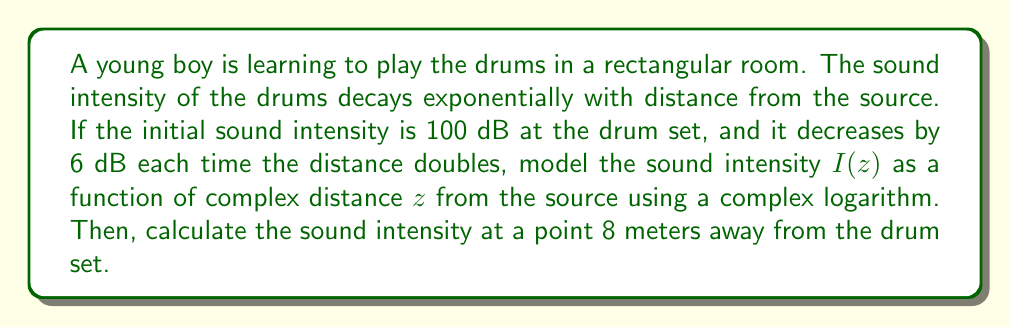Could you help me with this problem? Let's approach this problem step by step:

1) First, we need to understand the relationship between sound intensity and distance. The given information states that the intensity decreases by 6 dB each time the distance doubles. This is a logarithmic relationship.

2) We can model this using the complex logarithm function. Let's define our function:

   $$I(z) = I_0 \cdot 2^{-\frac{\log_2|z|}{\log_2 2}}$$

   where $I_0$ is the initial intensity, and $z$ is the complex distance from the source.

3) Simplify the exponent:

   $$I(z) = I_0 \cdot 2^{-\log_2|z|}$$

4) Using the properties of logarithms, we can rewrite this as:

   $$I(z) = I_0 \cdot |z|^{-1}$$

5) Now, we need to incorporate the 6 dB decrease for each doubling of distance. Remember that decibels are on a logarithmic scale. A decrease of 6 dB corresponds to dividing the intensity by 4.

6) So, our final model becomes:

   $$I(z) = I_0 \cdot (|z|^2)^{-1} = \frac{I_0}{|z|^2}$$

7) Given that $I_0 = 100$ dB, our final model is:

   $$I(z) = \frac{100}{|z|^2}$$

8) To find the intensity at 8 meters, we simply substitute $|z| = 8$:

   $$I(8) = \frac{100}{8^2} = \frac{100}{64} = 1.5625$$

Therefore, the sound intensity 8 meters away from the drum set is approximately 1.5625 dB.
Answer: The sound intensity model is $I(z) = \frac{100}{|z|^2}$ dB, where $z$ is the complex distance from the source. At 8 meters from the drum set, the sound intensity is approximately 1.5625 dB. 